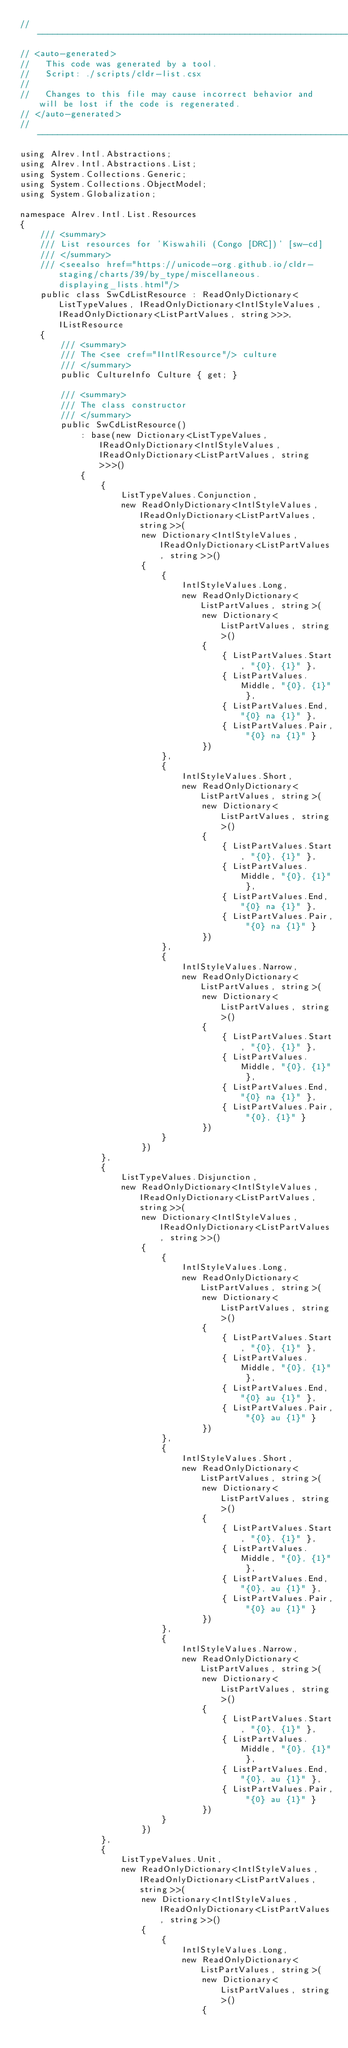<code> <loc_0><loc_0><loc_500><loc_500><_C#_>// --------------------------------------------------------------------------------------------------
// <auto-generated>
//   This code was generated by a tool.
//   Script: ./scripts/cldr-list.csx
//
//   Changes to this file may cause incorrect behavior and will be lost if the code is regenerated.
// </auto-generated>
// --------------------------------------------------------------------------------------------------
using Alrev.Intl.Abstractions;
using Alrev.Intl.Abstractions.List;
using System.Collections.Generic;
using System.Collections.ObjectModel;
using System.Globalization;

namespace Alrev.Intl.List.Resources
{
	/// <summary>
	/// List resources for 'Kiswahili (Congo [DRC])' [sw-cd]
	/// </summary>
	/// <seealso href="https://unicode-org.github.io/cldr-staging/charts/39/by_type/miscellaneous.displaying_lists.html"/>
	public class SwCdListResource : ReadOnlyDictionary<ListTypeValues, IReadOnlyDictionary<IntlStyleValues, IReadOnlyDictionary<ListPartValues, string>>>, IListResource
	{
		/// <summary>
		/// The <see cref="IIntlResource"/> culture
		/// </summary>
		public CultureInfo Culture { get; }

		/// <summary>
		/// The class constructor
		/// </summary>
		public SwCdListResource()
			: base(new Dictionary<ListTypeValues, IReadOnlyDictionary<IntlStyleValues, IReadOnlyDictionary<ListPartValues, string>>>()
			{
				{
					ListTypeValues.Conjunction,
					new ReadOnlyDictionary<IntlStyleValues, IReadOnlyDictionary<ListPartValues, string>>(
						new Dictionary<IntlStyleValues, IReadOnlyDictionary<ListPartValues, string>>()
						{
							{
								IntlStyleValues.Long,
								new ReadOnlyDictionary<ListPartValues, string>(
									new Dictionary<ListPartValues, string>()
									{
										{ ListPartValues.Start, "{0}, {1}" },
										{ ListPartValues.Middle, "{0}, {1}" },
										{ ListPartValues.End, "{0} na {1}" },
										{ ListPartValues.Pair, "{0} na {1}" }
									})
							},
							{
								IntlStyleValues.Short,
								new ReadOnlyDictionary<ListPartValues, string>(
									new Dictionary<ListPartValues, string>()
									{
										{ ListPartValues.Start, "{0}, {1}" },
										{ ListPartValues.Middle, "{0}, {1}" },
										{ ListPartValues.End, "{0} na {1}" },
										{ ListPartValues.Pair, "{0} na {1}" }
									})
							},
							{
								IntlStyleValues.Narrow,
								new ReadOnlyDictionary<ListPartValues, string>(
									new Dictionary<ListPartValues, string>()
									{
										{ ListPartValues.Start, "{0}, {1}" },
										{ ListPartValues.Middle, "{0}, {1}" },
										{ ListPartValues.End, "{0} na {1}" },
										{ ListPartValues.Pair, "{0}, {1}" }
									})
							}
						})
				},
				{
					ListTypeValues.Disjunction,
					new ReadOnlyDictionary<IntlStyleValues, IReadOnlyDictionary<ListPartValues, string>>(
						new Dictionary<IntlStyleValues, IReadOnlyDictionary<ListPartValues, string>>()
						{
							{
								IntlStyleValues.Long,
								new ReadOnlyDictionary<ListPartValues, string>(
									new Dictionary<ListPartValues, string>()
									{
										{ ListPartValues.Start, "{0}, {1}" },
										{ ListPartValues.Middle, "{0}, {1}" },
										{ ListPartValues.End, "{0} au {1}" },
										{ ListPartValues.Pair, "{0} au {1}" }
									})
							},
							{
								IntlStyleValues.Short,
								new ReadOnlyDictionary<ListPartValues, string>(
									new Dictionary<ListPartValues, string>()
									{
										{ ListPartValues.Start, "{0}, {1}" },
										{ ListPartValues.Middle, "{0}, {1}" },
										{ ListPartValues.End, "{0}, au {1}" },
										{ ListPartValues.Pair, "{0} au {1}" }
									})
							},
							{
								IntlStyleValues.Narrow,
								new ReadOnlyDictionary<ListPartValues, string>(
									new Dictionary<ListPartValues, string>()
									{
										{ ListPartValues.Start, "{0}, {1}" },
										{ ListPartValues.Middle, "{0}, {1}" },
										{ ListPartValues.End, "{0}, au {1}" },
										{ ListPartValues.Pair, "{0} au {1}" }
									})
							}
						})
				},
				{
					ListTypeValues.Unit,
					new ReadOnlyDictionary<IntlStyleValues, IReadOnlyDictionary<ListPartValues, string>>(
						new Dictionary<IntlStyleValues, IReadOnlyDictionary<ListPartValues, string>>()
						{
							{
								IntlStyleValues.Long,
								new ReadOnlyDictionary<ListPartValues, string>(
									new Dictionary<ListPartValues, string>()
									{</code> 